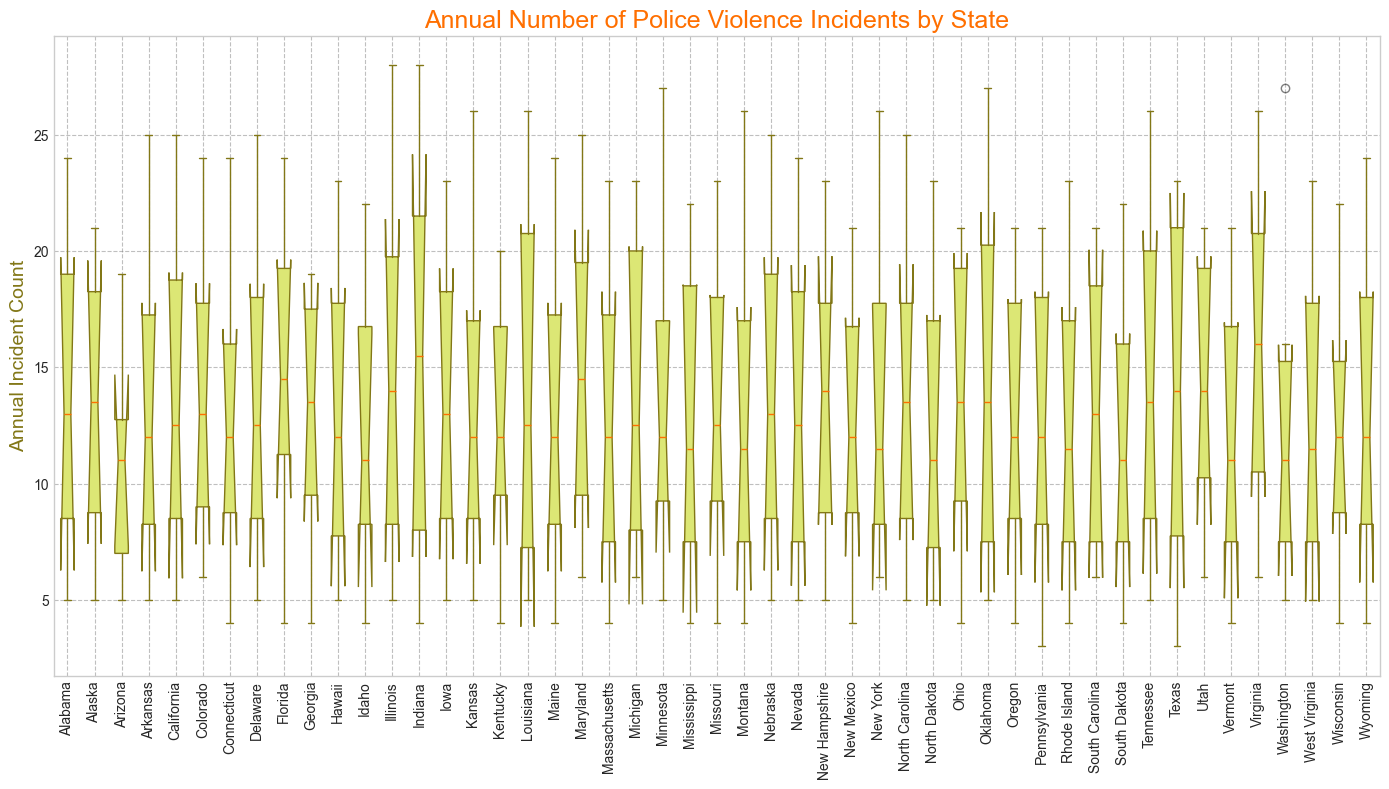Which state has the highest median annual incident count? Look at the central line inside each box in the box plot, representing the median. Identify the state with the highest median line.
Answer: Illinois Which state has the lowest median annual incident count? Look at the central line inside each box and find the state with the line closest to the bottom.
Answer: New Mexico Which states have the widest range of annual incident counts? Identify the states where the distance between the whiskers (the bottom and top lines of the box plot) is the greatest.
Answer: Texas, Illinois, and North Carolina Which state has the most consistent (smallest range) annual incident counts? Look for the state with the shortest distance between the whiskers.
Answer: New Mexico How does the median incident count of California compare to Florida? Compare the central lines inside the boxes of both states.
Answer: California's median is slightly higher than Florida's median Is there any state where the minimum annual incident count is 3 or lower? Check if any state's box plot has whiskers or outliers below the value of 4.
Answer: Texas Which state(s) shows an outlier in annual incident counts, and what is the visual indicator? Identify the state(s) with points marked outside the whiskers of the box plot. Outliers are typically marked with circles.
Answer: Texas (at the bottom) and Illinois (at the top) What is the interquartile range (IQR) for Ohio? Calculate the difference between the upper quartile (top edge of the box) and the lower quartile (bottom edge of the box) for Ohio's box plot.
Answer: IQR for Ohio is not directly measurable from the figure, exact values needed How do the incident ranges for severe levels compare between Virginia and Iowa? Compare the lengths of the whiskers and boxes between Virginia and Iowa.
Answer: Virginia has a wider range for incidents compared to Iowa Are the incident counts for severity level 3 generally higher or lower than the other severity levels? Observe the positions of boxes and their distribution for the severity level 3 incidents in comparison to others.
Answer: Generally lower than severity levels 1 and 2 